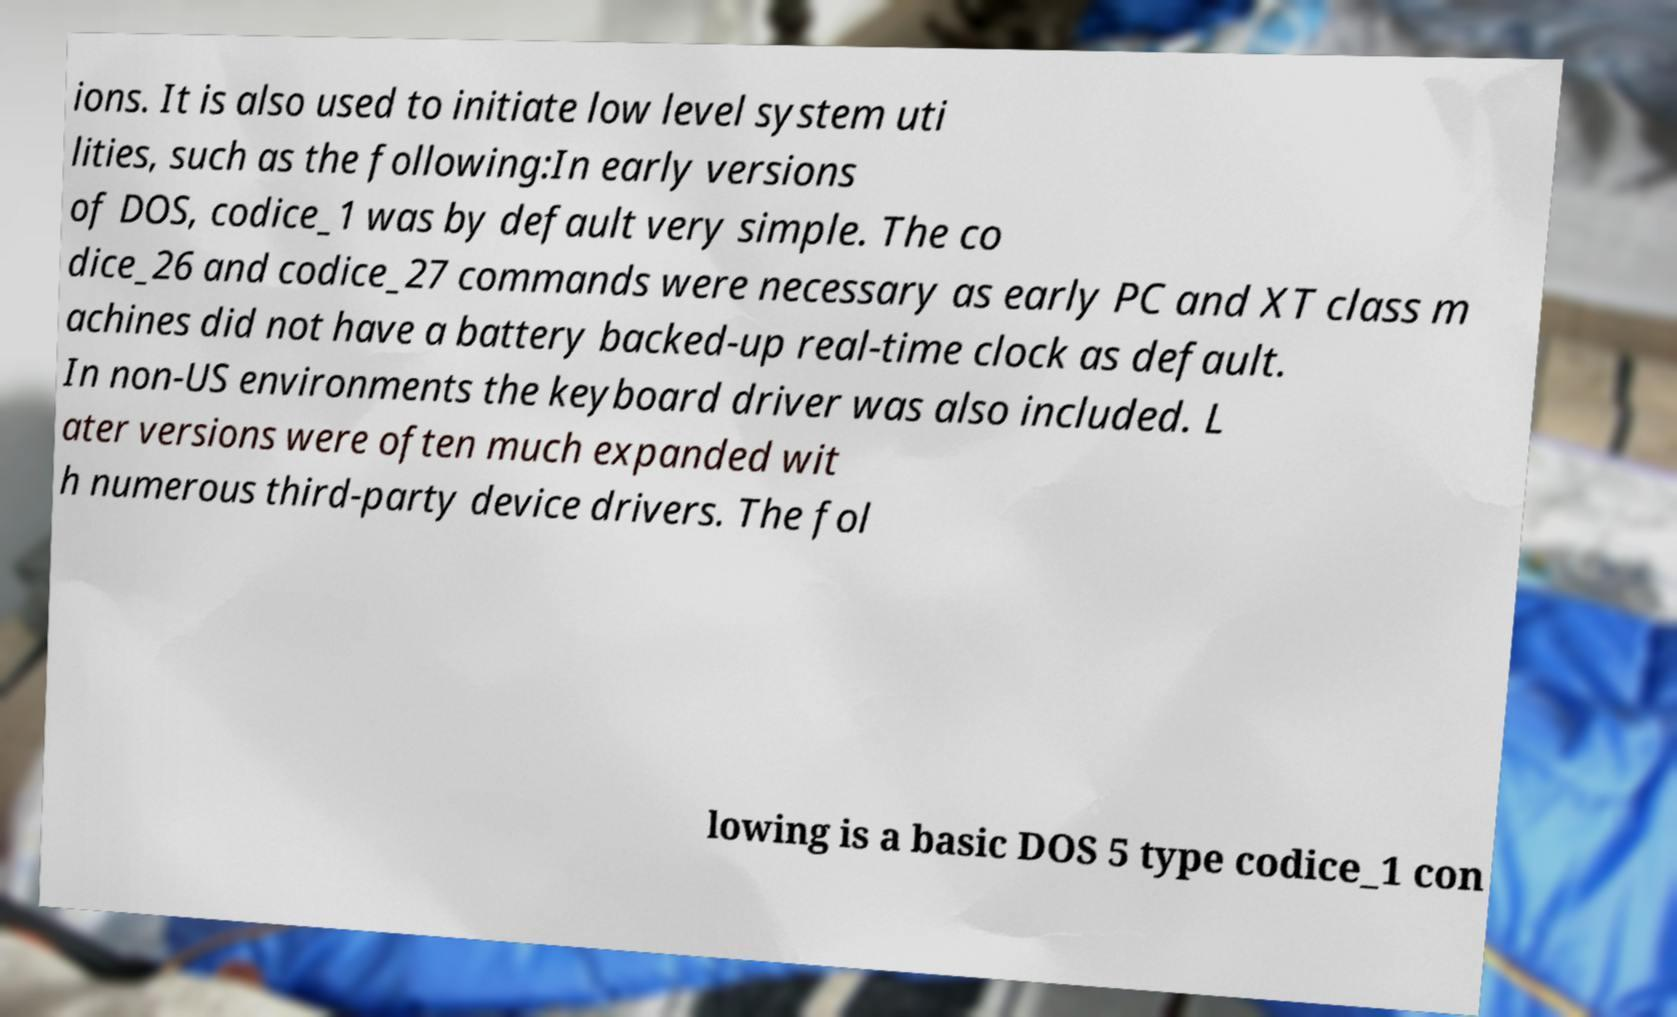There's text embedded in this image that I need extracted. Can you transcribe it verbatim? ions. It is also used to initiate low level system uti lities, such as the following:In early versions of DOS, codice_1 was by default very simple. The co dice_26 and codice_27 commands were necessary as early PC and XT class m achines did not have a battery backed-up real-time clock as default. In non-US environments the keyboard driver was also included. L ater versions were often much expanded wit h numerous third-party device drivers. The fol lowing is a basic DOS 5 type codice_1 con 